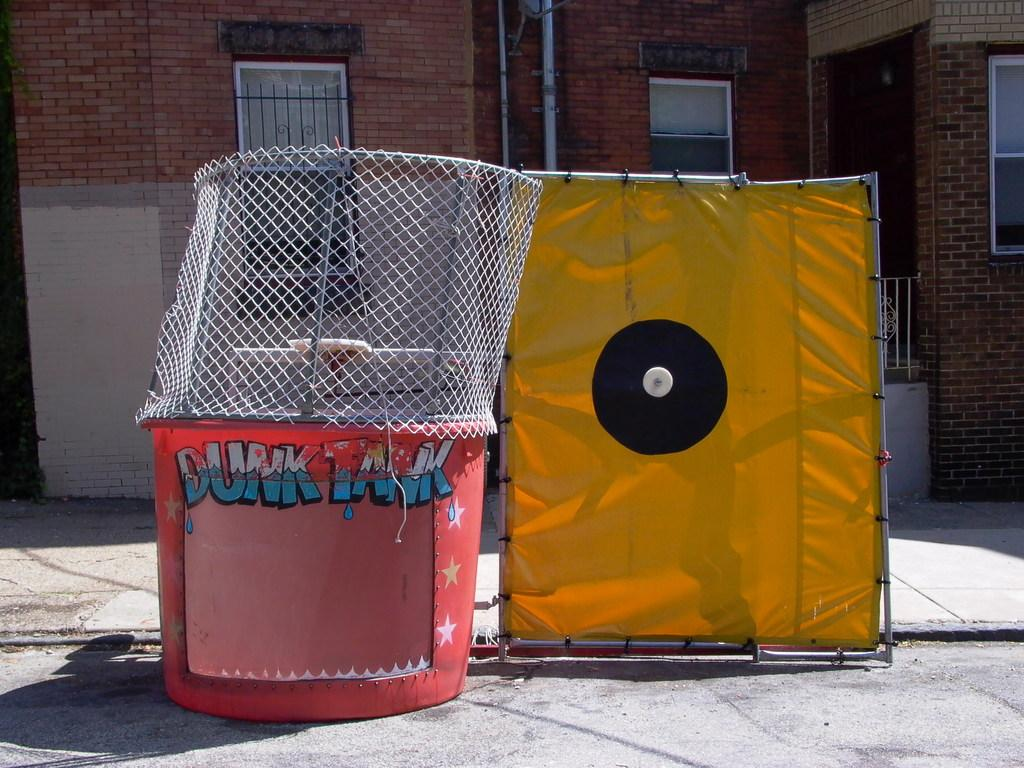Provide a one-sentence caption for the provided image. A red "dunk tank" sits next to a yellow cloth outside of a building. 